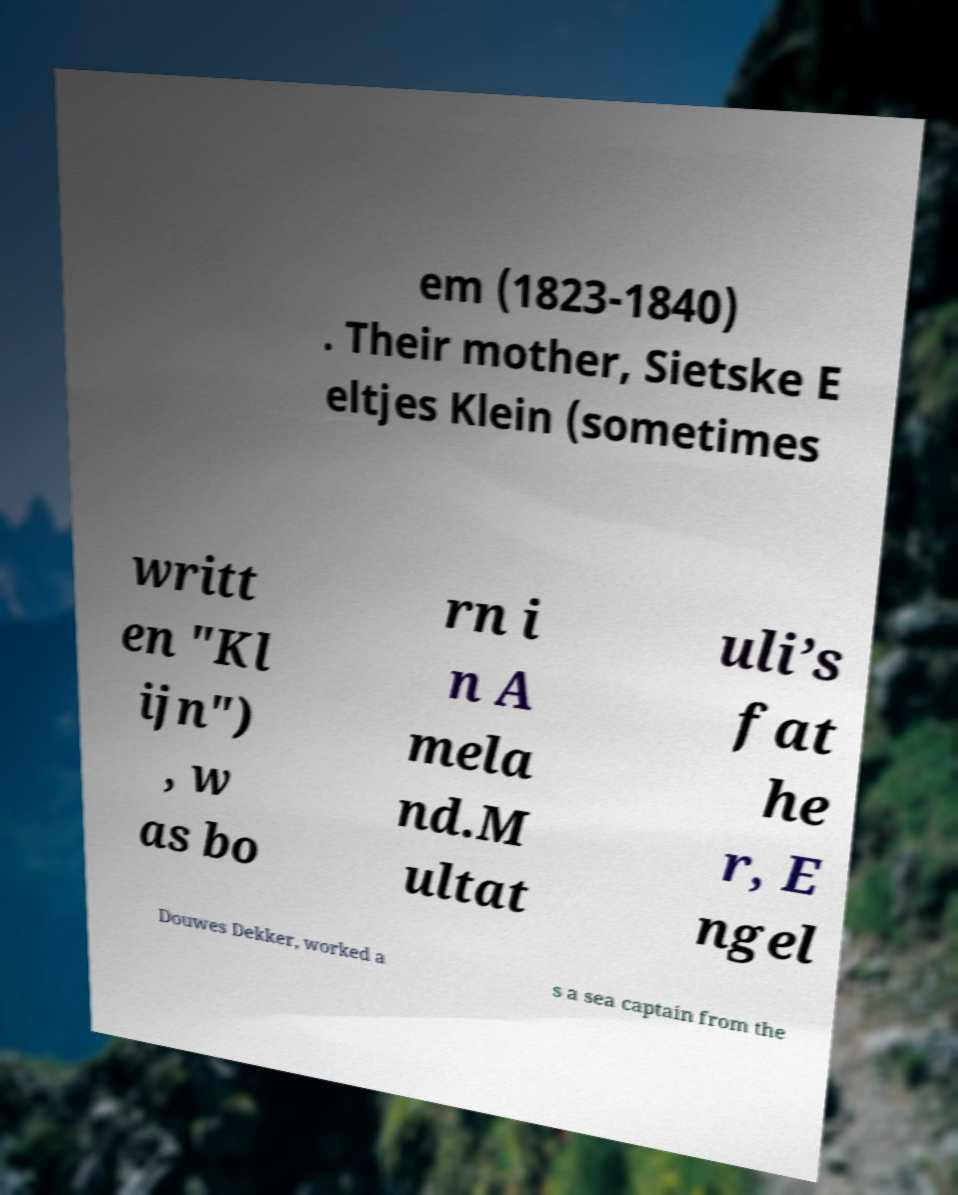There's text embedded in this image that I need extracted. Can you transcribe it verbatim? em (1823-1840) . Their mother, Sietske E eltjes Klein (sometimes writt en "Kl ijn") , w as bo rn i n A mela nd.M ultat uli’s fat he r, E ngel Douwes Dekker, worked a s a sea captain from the 